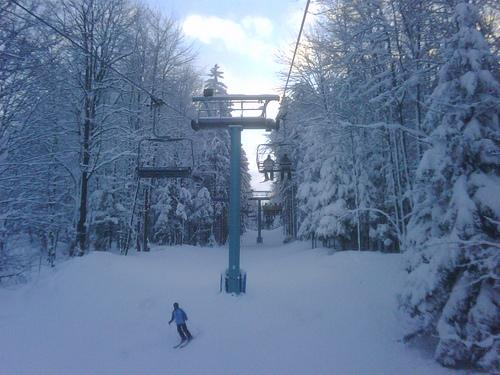Where are the people on the wire going? up mountain 